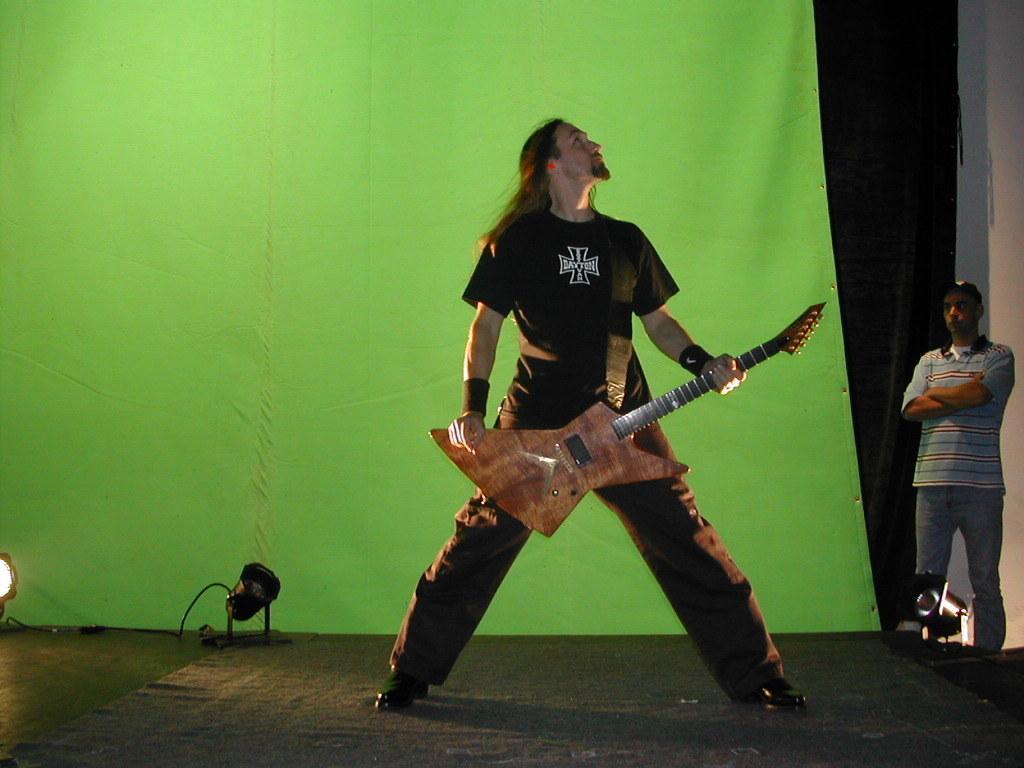Please provide a concise description of this image. This picture shows a Man Standing and holding a guitar in his hand and we see a other man standing on the back 